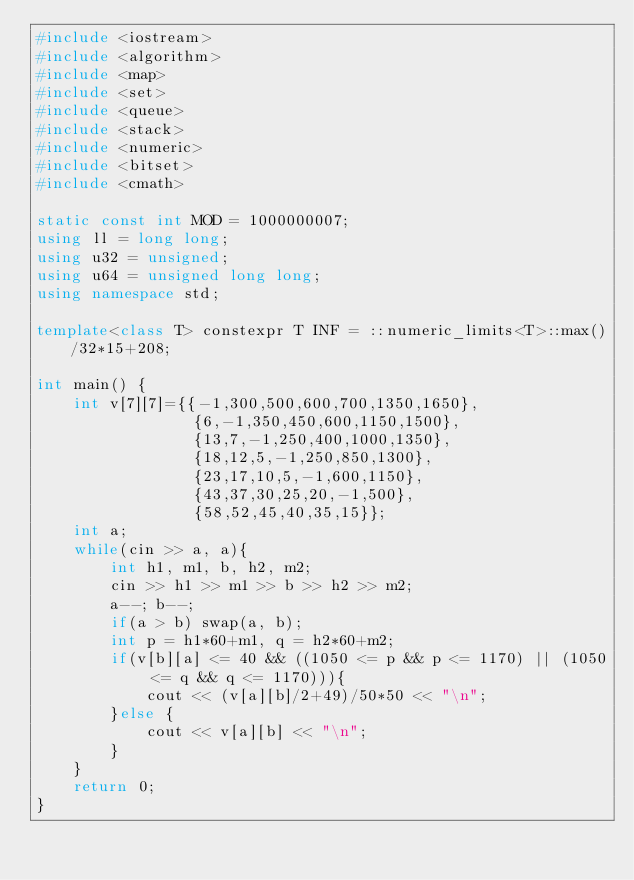<code> <loc_0><loc_0><loc_500><loc_500><_C++_>#include <iostream>
#include <algorithm>
#include <map>
#include <set>
#include <queue>
#include <stack>
#include <numeric>
#include <bitset>
#include <cmath>

static const int MOD = 1000000007;
using ll = long long;
using u32 = unsigned;
using u64 = unsigned long long;
using namespace std;

template<class T> constexpr T INF = ::numeric_limits<T>::max()/32*15+208;

int main() {
    int v[7][7]={{-1,300,500,600,700,1350,1650},
                 {6,-1,350,450,600,1150,1500},
                 {13,7,-1,250,400,1000,1350},
                 {18,12,5,-1,250,850,1300},
                 {23,17,10,5,-1,600,1150},
                 {43,37,30,25,20,-1,500},
                 {58,52,45,40,35,15}};
    int a;
    while(cin >> a, a){
        int h1, m1, b, h2, m2;
        cin >> h1 >> m1 >> b >> h2 >> m2;
        a--; b--;
        if(a > b) swap(a, b);
        int p = h1*60+m1, q = h2*60+m2;
        if(v[b][a] <= 40 && ((1050 <= p && p <= 1170) || (1050 <= q && q <= 1170))){
            cout << (v[a][b]/2+49)/50*50 << "\n";
        }else {
            cout << v[a][b] << "\n";
        }
    }
    return 0;
}
</code> 